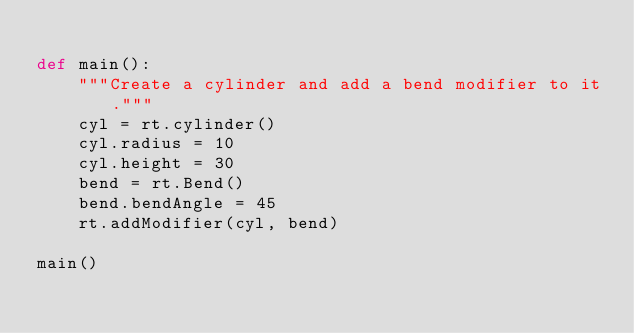<code> <loc_0><loc_0><loc_500><loc_500><_Python_>
def main():
    """Create a cylinder and add a bend modifier to it."""
    cyl = rt.cylinder()
    cyl.radius = 10
    cyl.height = 30
    bend = rt.Bend()
    bend.bendAngle = 45
    rt.addModifier(cyl, bend)

main()
</code> 